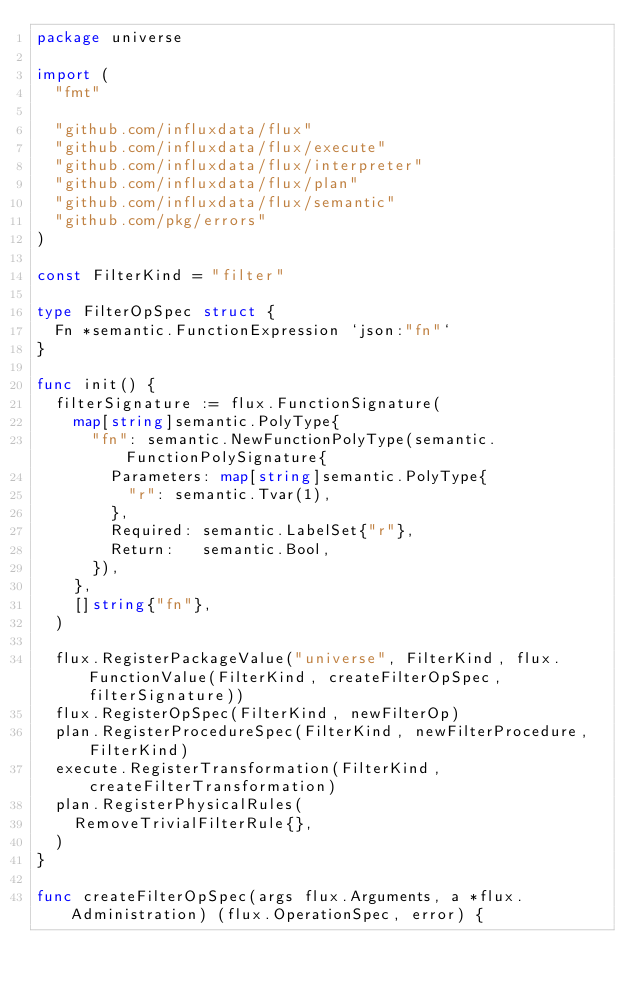<code> <loc_0><loc_0><loc_500><loc_500><_Go_>package universe

import (
	"fmt"

	"github.com/influxdata/flux"
	"github.com/influxdata/flux/execute"
	"github.com/influxdata/flux/interpreter"
	"github.com/influxdata/flux/plan"
	"github.com/influxdata/flux/semantic"
	"github.com/pkg/errors"
)

const FilterKind = "filter"

type FilterOpSpec struct {
	Fn *semantic.FunctionExpression `json:"fn"`
}

func init() {
	filterSignature := flux.FunctionSignature(
		map[string]semantic.PolyType{
			"fn": semantic.NewFunctionPolyType(semantic.FunctionPolySignature{
				Parameters: map[string]semantic.PolyType{
					"r": semantic.Tvar(1),
				},
				Required: semantic.LabelSet{"r"},
				Return:   semantic.Bool,
			}),
		},
		[]string{"fn"},
	)

	flux.RegisterPackageValue("universe", FilterKind, flux.FunctionValue(FilterKind, createFilterOpSpec, filterSignature))
	flux.RegisterOpSpec(FilterKind, newFilterOp)
	plan.RegisterProcedureSpec(FilterKind, newFilterProcedure, FilterKind)
	execute.RegisterTransformation(FilterKind, createFilterTransformation)
	plan.RegisterPhysicalRules(
		RemoveTrivialFilterRule{},
	)
}

func createFilterOpSpec(args flux.Arguments, a *flux.Administration) (flux.OperationSpec, error) {</code> 